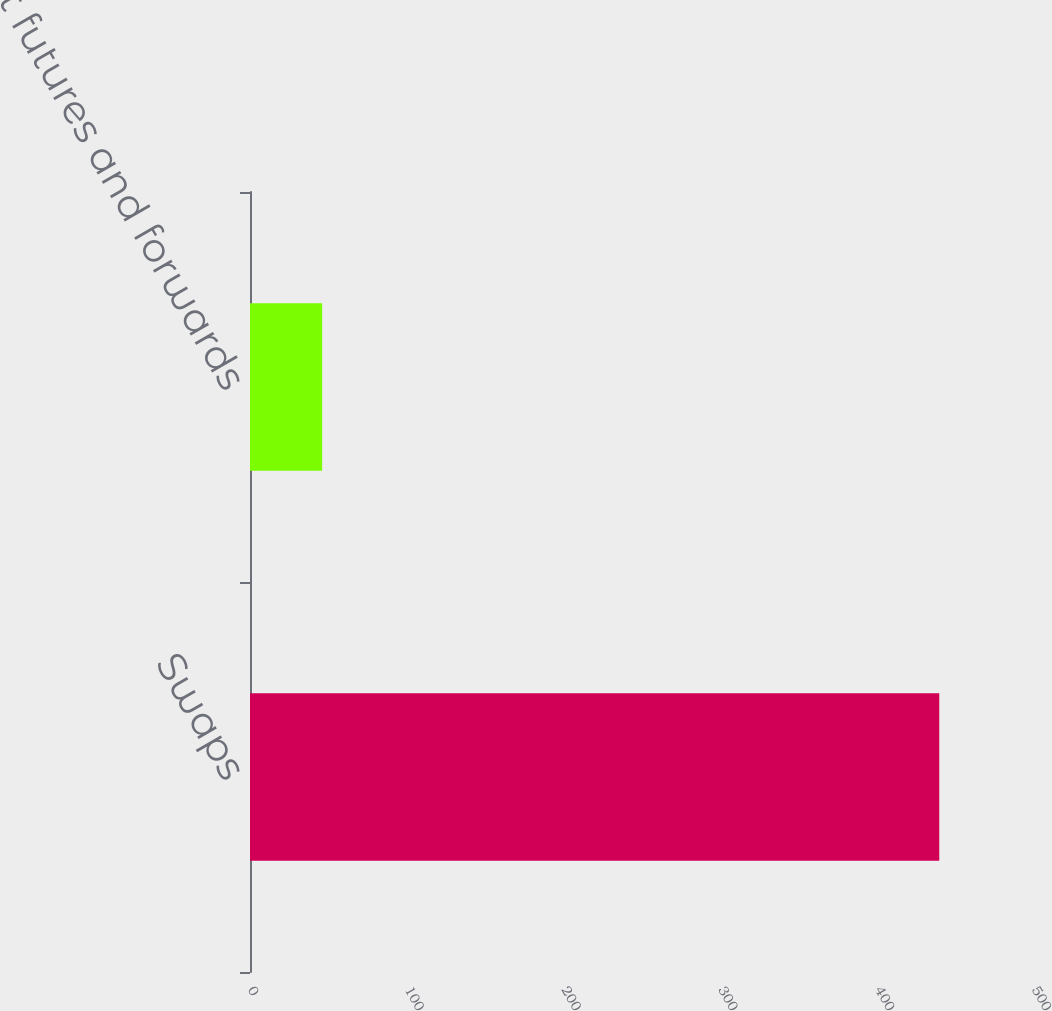Convert chart to OTSL. <chart><loc_0><loc_0><loc_500><loc_500><bar_chart><fcel>Swaps<fcel>Spot futures and forwards<nl><fcel>439.6<fcel>46<nl></chart> 